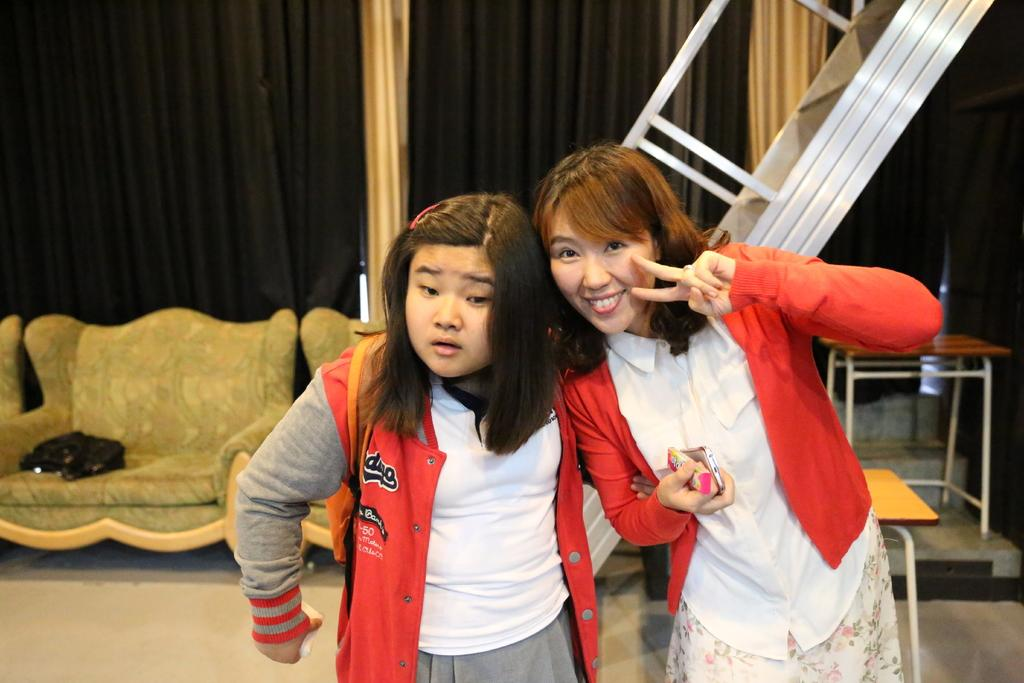How many women are in the image? There are two women in the image. What are the women wearing? The women are wearing clothes. What are the women holding in their hands? The women are holding objects in their hands. What is the floor like in the image? There is a floor visible in the image. What type of furniture can be seen in the image? There is a sofa and a table in the image. What type of window treatment is present in the image? There are curtains in the image. What time of day is it in the image, and what is the women's occupation as spies? The time of day is not mentioned in the image, and there is no indication that the women are spies. 